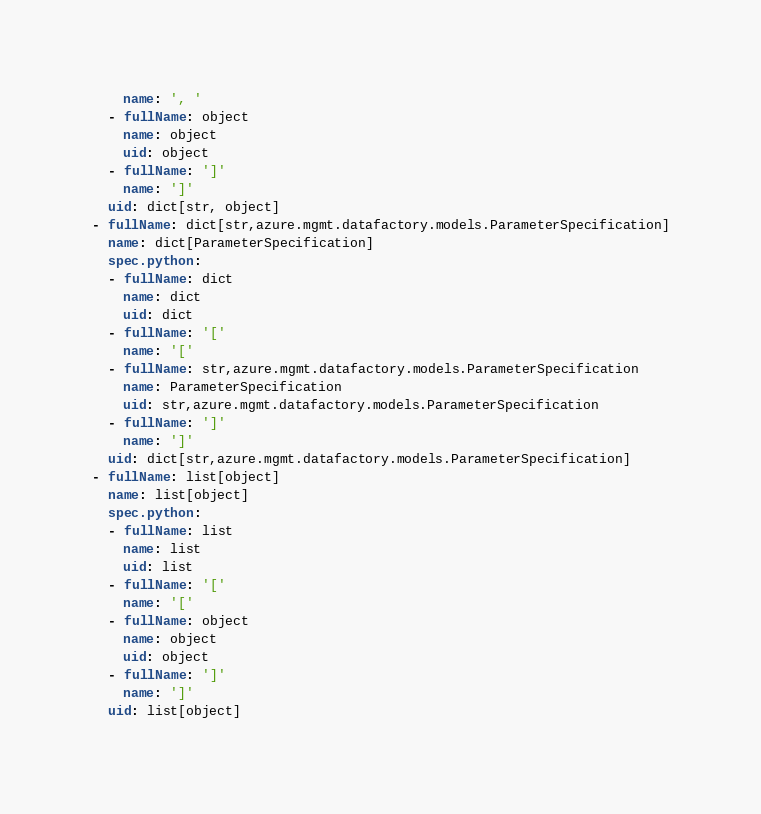<code> <loc_0><loc_0><loc_500><loc_500><_YAML_>    name: ', '
  - fullName: object
    name: object
    uid: object
  - fullName: ']'
    name: ']'
  uid: dict[str, object]
- fullName: dict[str,azure.mgmt.datafactory.models.ParameterSpecification]
  name: dict[ParameterSpecification]
  spec.python:
  - fullName: dict
    name: dict
    uid: dict
  - fullName: '['
    name: '['
  - fullName: str,azure.mgmt.datafactory.models.ParameterSpecification
    name: ParameterSpecification
    uid: str,azure.mgmt.datafactory.models.ParameterSpecification
  - fullName: ']'
    name: ']'
  uid: dict[str,azure.mgmt.datafactory.models.ParameterSpecification]
- fullName: list[object]
  name: list[object]
  spec.python:
  - fullName: list
    name: list
    uid: list
  - fullName: '['
    name: '['
  - fullName: object
    name: object
    uid: object
  - fullName: ']'
    name: ']'
  uid: list[object]
</code> 